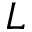<formula> <loc_0><loc_0><loc_500><loc_500>L</formula> 